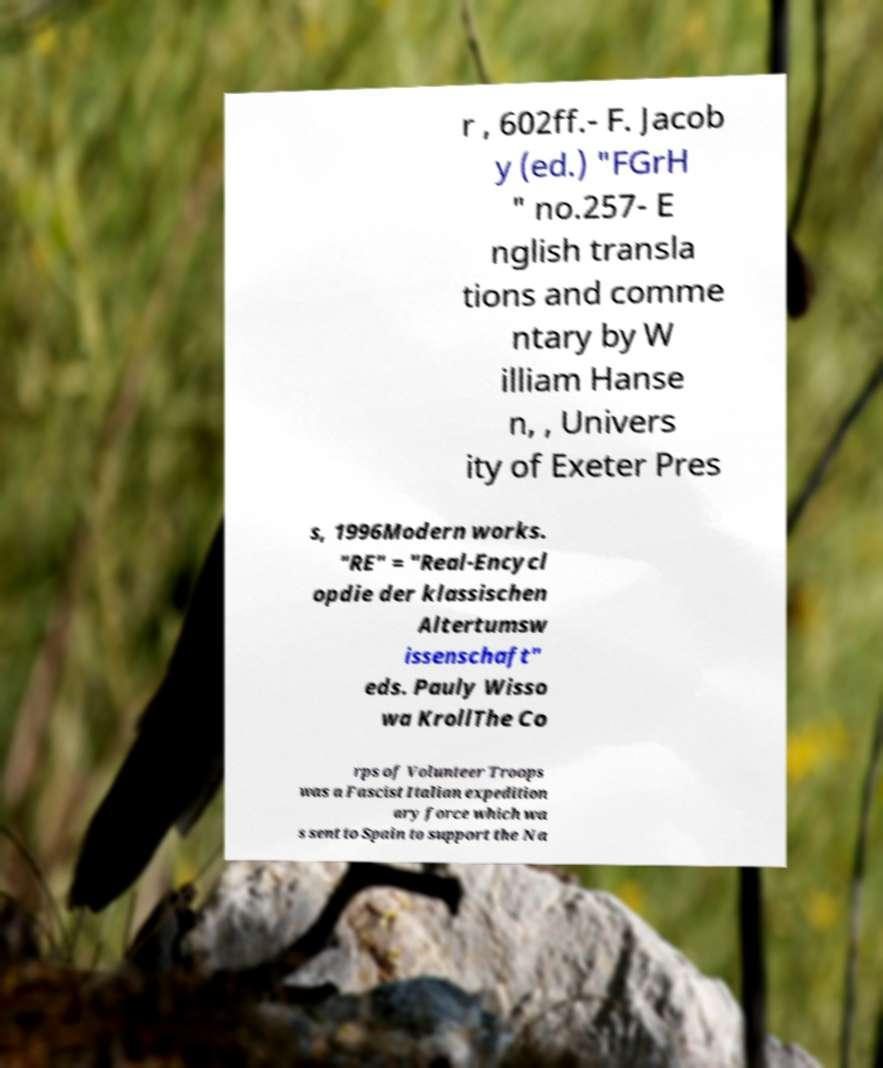Please identify and transcribe the text found in this image. r , 602ff.- F. Jacob y (ed.) "FGrH " no.257- E nglish transla tions and comme ntary by W illiam Hanse n, , Univers ity of Exeter Pres s, 1996Modern works. "RE" = "Real-Encycl opdie der klassischen Altertumsw issenschaft" eds. Pauly Wisso wa KrollThe Co rps of Volunteer Troops was a Fascist Italian expedition ary force which wa s sent to Spain to support the Na 